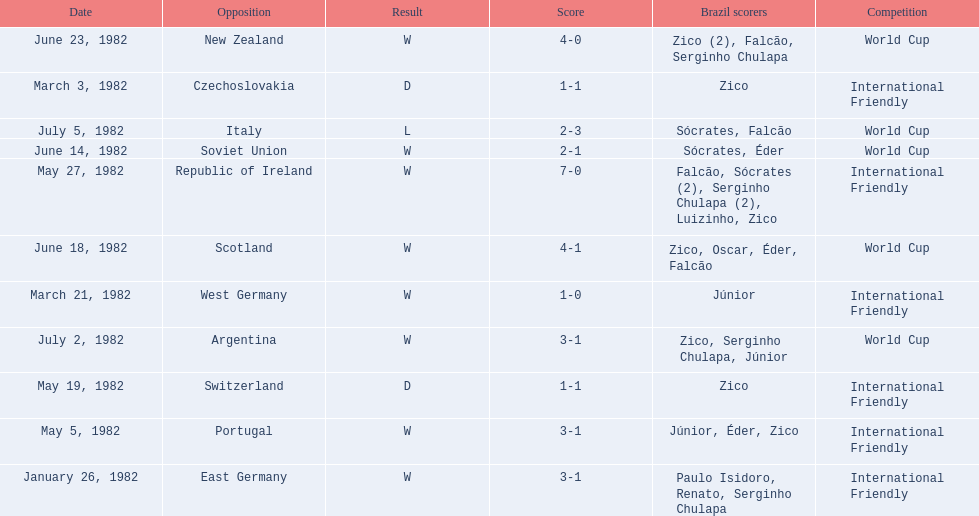Parse the full table in json format. {'header': ['Date', 'Opposition', 'Result', 'Score', 'Brazil scorers', 'Competition'], 'rows': [['June 23, 1982', 'New Zealand', 'W', '4-0', 'Zico (2), Falcão, Serginho Chulapa', 'World Cup'], ['March 3, 1982', 'Czechoslovakia', 'D', '1-1', 'Zico', 'International Friendly'], ['July 5, 1982', 'Italy', 'L', '2-3', 'Sócrates, Falcão', 'World Cup'], ['June 14, 1982', 'Soviet Union', 'W', '2-1', 'Sócrates, Éder', 'World Cup'], ['May 27, 1982', 'Republic of Ireland', 'W', '7-0', 'Falcão, Sócrates (2), Serginho Chulapa (2), Luizinho, Zico', 'International Friendly'], ['June 18, 1982', 'Scotland', 'W', '4-1', 'Zico, Oscar, Éder, Falcão', 'World Cup'], ['March 21, 1982', 'West Germany', 'W', '1-0', 'Júnior', 'International Friendly'], ['July 2, 1982', 'Argentina', 'W', '3-1', 'Zico, Serginho Chulapa, Júnior', 'World Cup'], ['May 19, 1982', 'Switzerland', 'D', '1-1', 'Zico', 'International Friendly'], ['May 5, 1982', 'Portugal', 'W', '3-1', 'Júnior, Éder, Zico', 'International Friendly'], ['January 26, 1982', 'East Germany', 'W', '3-1', 'Paulo Isidoro, Renato, Serginho Chulapa', 'International Friendly']]} What were the scores of each of game in the 1982 brazilian football games? 3-1, 1-1, 1-0, 3-1, 1-1, 7-0, 2-1, 4-1, 4-0, 3-1, 2-3. Of those, which were scores from games against portugal and the soviet union? 3-1, 2-1. And between those two games, against which country did brazil score more goals? Portugal. 